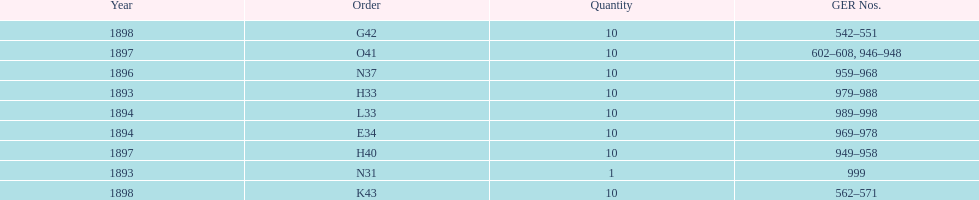What is the number of years with a quantity of 10? 5. 